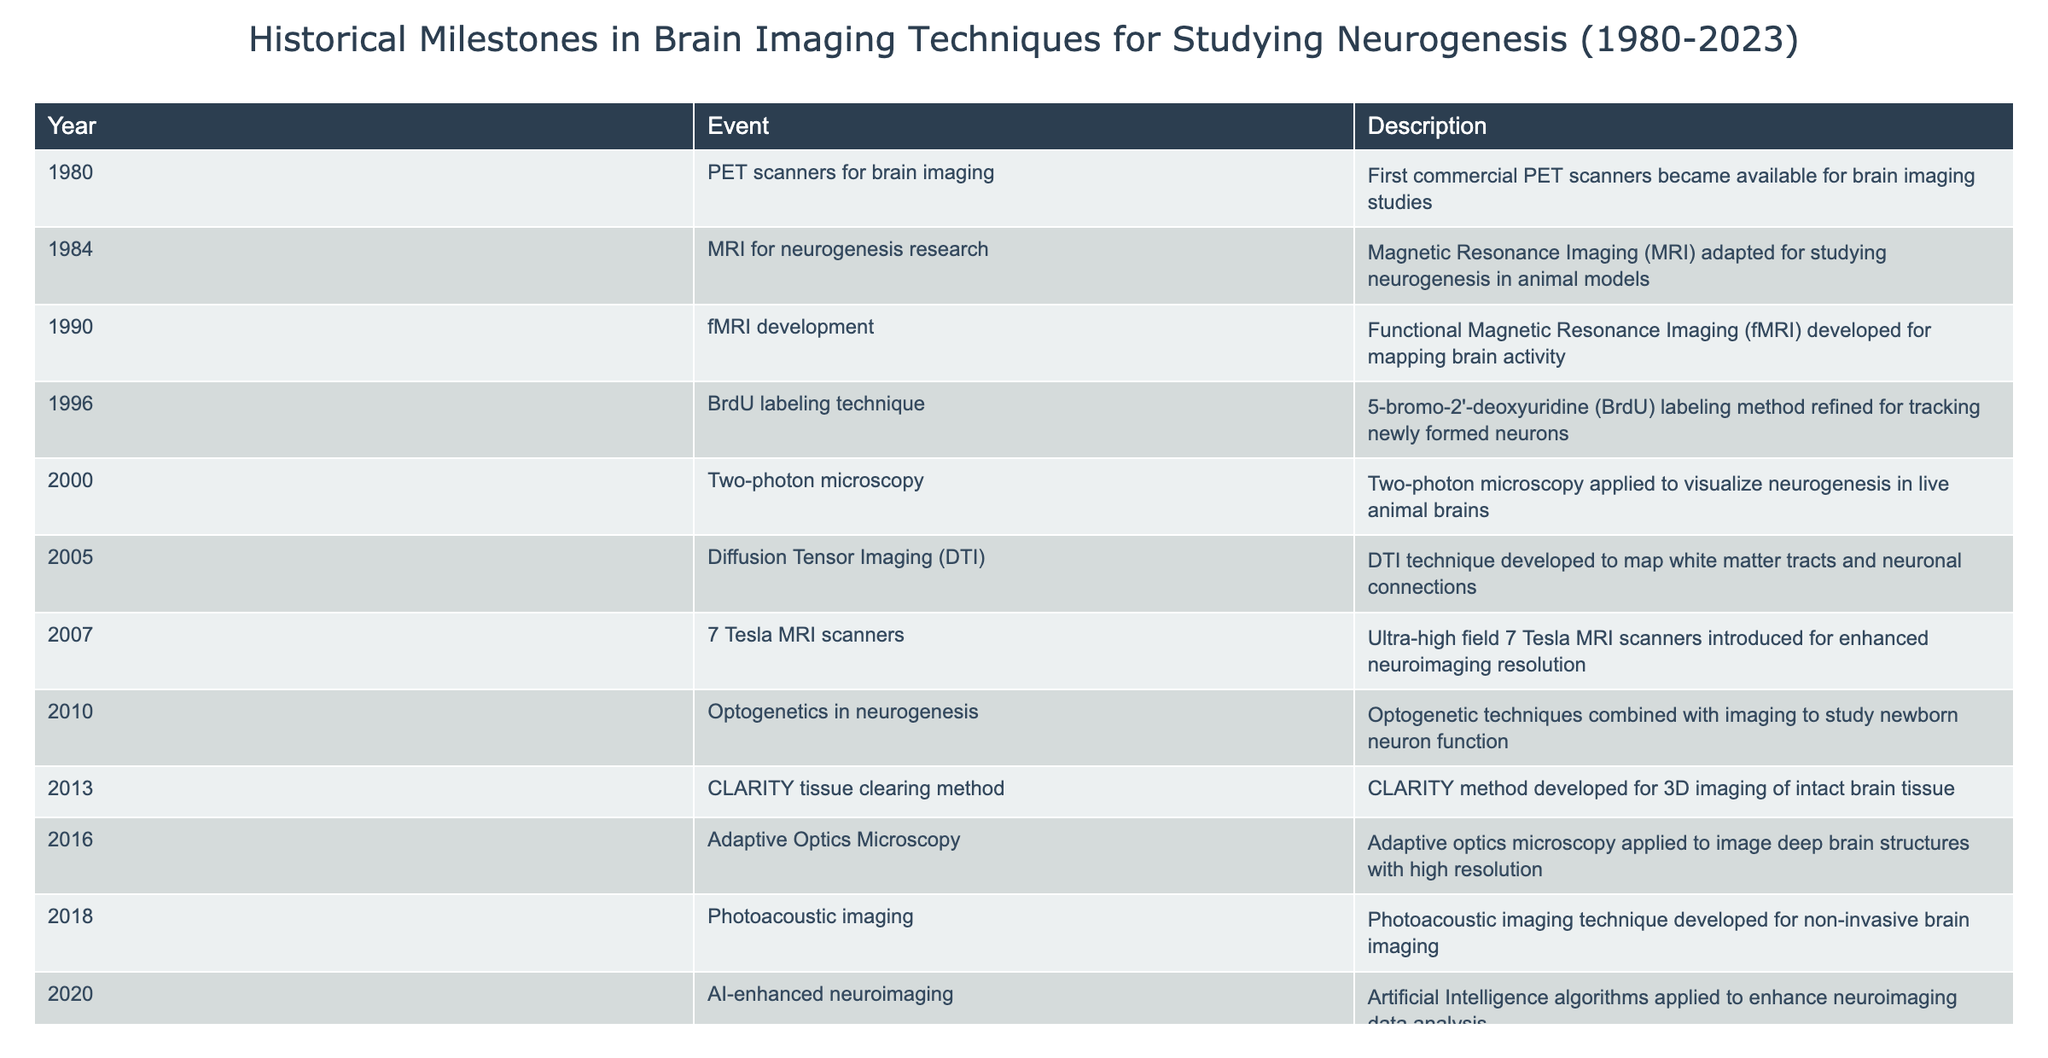What event marked the introduction of PET scanners for brain imaging? The table states that the first commercial PET scanners became available in 1980 for brain imaging studies.
Answer: 1980 Which imaging technique was adapted for studying neurogenesis in animal models in 1984? The table indicates that MRI was adapted for studying neurogenesis in animal models in 1984.
Answer: MRI In what year did fMRI get developed for mapping brain activity? According to the table, fMRI was developed in 1990 for mapping brain activity.
Answer: 1990 How many years passed between the refinement of the BrdU labeling technique and the introduction of 7 Tesla MRI scanners? The BrdU labeling technique was refined in 1996 and 7 Tesla MRI scanners were introduced in 2007, which is a difference of 11 years (2007 - 1996).
Answer: 11 years True or False: The CLARITY tissue clearing method was developed before the diffusion tensor imaging technique. The table shows that DTI was developed in 2005 and CLARITY in 2013, so CLARITY was developed after DTI.
Answer: False What was the significance of the advancements made in brain imaging techniques from 1980 to 2010? The table lists multiple advancements including PET, MRI, fMRI, and optogenetics which improved the understanding of neurogenesis and brain function.
Answer: Improved understanding of neurogenesis During which decade was Quantum sensing for neuroimaging developed? Referring to the table, Quantum sensing for neuroimaging was developed in 2023, which is in the 2020s.
Answer: 2020s Which imaging technique was first introduced to visualize neurogenesis in live animal brains, and in what year was it introduced? According to the table, two-photon microscopy was applied for this purpose in 2000.
Answer: Two-photon microscopy, 2000 List the imaging techniques that were developed or refined in the 2000s. From the table, the techniques developed in the 2000s include Two-photon microscopy in 2000, DTI in 2005, and optogenetics in 2010.
Answer: Two-photon microscopy, DTI, optogenetics 